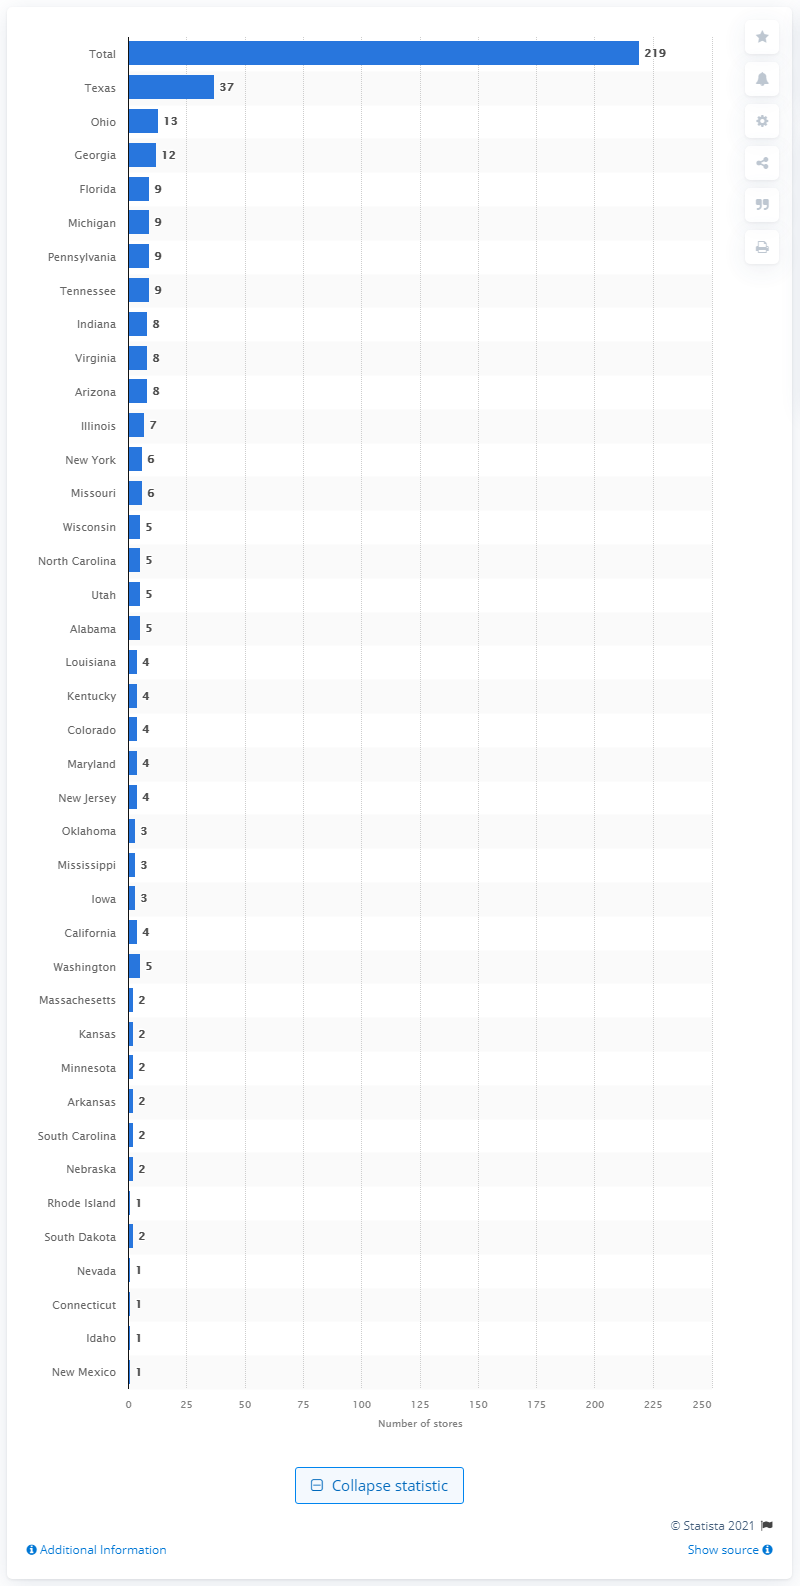Indicate a few pertinent items in this graphic. As of January 30, 2021, At Home had 219 stores in the United States. As of January 30, 2021, At Home had a total of 37 stores operating in the state of Texas. 